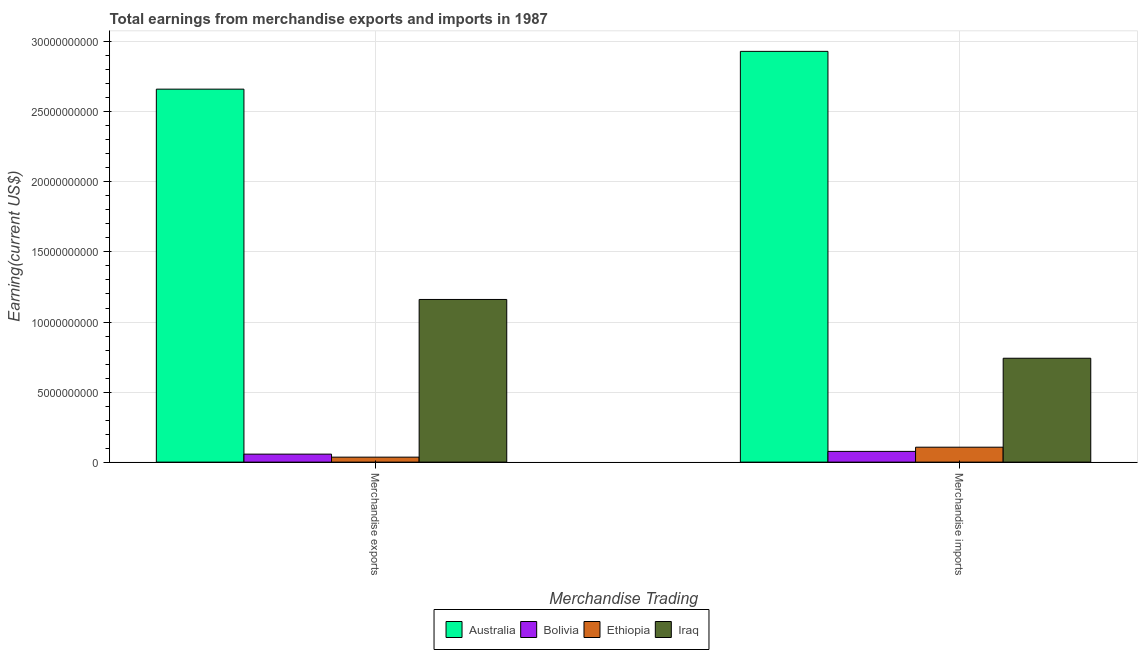Are the number of bars per tick equal to the number of legend labels?
Give a very brief answer. Yes. Are the number of bars on each tick of the X-axis equal?
Your answer should be compact. Yes. How many bars are there on the 2nd tick from the left?
Offer a very short reply. 4. How many bars are there on the 2nd tick from the right?
Offer a very short reply. 4. What is the label of the 1st group of bars from the left?
Your answer should be compact. Merchandise exports. What is the earnings from merchandise imports in Iraq?
Ensure brevity in your answer.  7.42e+09. Across all countries, what is the maximum earnings from merchandise imports?
Offer a very short reply. 2.93e+1. Across all countries, what is the minimum earnings from merchandise exports?
Offer a very short reply. 3.55e+08. In which country was the earnings from merchandise imports maximum?
Your answer should be compact. Australia. What is the total earnings from merchandise exports in the graph?
Provide a succinct answer. 3.92e+1. What is the difference between the earnings from merchandise imports in Bolivia and that in Iraq?
Make the answer very short. -6.65e+09. What is the difference between the earnings from merchandise exports in Bolivia and the earnings from merchandise imports in Australia?
Keep it short and to the point. -2.87e+1. What is the average earnings from merchandise imports per country?
Provide a succinct answer. 9.64e+09. What is the difference between the earnings from merchandise imports and earnings from merchandise exports in Australia?
Your answer should be very brief. 2.70e+09. In how many countries, is the earnings from merchandise exports greater than 5000000000 US$?
Provide a succinct answer. 2. What is the ratio of the earnings from merchandise imports in Australia to that in Bolivia?
Ensure brevity in your answer.  38.27. Is the earnings from merchandise imports in Iraq less than that in Bolivia?
Give a very brief answer. No. What does the 4th bar from the left in Merchandise imports represents?
Ensure brevity in your answer.  Iraq. What does the 1st bar from the right in Merchandise exports represents?
Your answer should be very brief. Iraq. How many bars are there?
Your answer should be compact. 8. Are the values on the major ticks of Y-axis written in scientific E-notation?
Provide a succinct answer. No. Where does the legend appear in the graph?
Your answer should be compact. Bottom center. How are the legend labels stacked?
Your answer should be very brief. Horizontal. What is the title of the graph?
Your answer should be compact. Total earnings from merchandise exports and imports in 1987. What is the label or title of the X-axis?
Give a very brief answer. Merchandise Trading. What is the label or title of the Y-axis?
Offer a terse response. Earning(current US$). What is the Earning(current US$) in Australia in Merchandise exports?
Ensure brevity in your answer.  2.66e+1. What is the Earning(current US$) in Bolivia in Merchandise exports?
Offer a terse response. 5.70e+08. What is the Earning(current US$) of Ethiopia in Merchandise exports?
Provide a succinct answer. 3.55e+08. What is the Earning(current US$) in Iraq in Merchandise exports?
Offer a terse response. 1.16e+1. What is the Earning(current US$) of Australia in Merchandise imports?
Offer a terse response. 2.93e+1. What is the Earning(current US$) in Bolivia in Merchandise imports?
Ensure brevity in your answer.  7.66e+08. What is the Earning(current US$) of Ethiopia in Merchandise imports?
Your answer should be compact. 1.07e+09. What is the Earning(current US$) in Iraq in Merchandise imports?
Give a very brief answer. 7.42e+09. Across all Merchandise Trading, what is the maximum Earning(current US$) of Australia?
Your answer should be very brief. 2.93e+1. Across all Merchandise Trading, what is the maximum Earning(current US$) in Bolivia?
Your response must be concise. 7.66e+08. Across all Merchandise Trading, what is the maximum Earning(current US$) in Ethiopia?
Your answer should be compact. 1.07e+09. Across all Merchandise Trading, what is the maximum Earning(current US$) of Iraq?
Your answer should be compact. 1.16e+1. Across all Merchandise Trading, what is the minimum Earning(current US$) in Australia?
Your answer should be compact. 2.66e+1. Across all Merchandise Trading, what is the minimum Earning(current US$) of Bolivia?
Keep it short and to the point. 5.70e+08. Across all Merchandise Trading, what is the minimum Earning(current US$) in Ethiopia?
Ensure brevity in your answer.  3.55e+08. Across all Merchandise Trading, what is the minimum Earning(current US$) of Iraq?
Make the answer very short. 7.42e+09. What is the total Earning(current US$) of Australia in the graph?
Keep it short and to the point. 5.59e+1. What is the total Earning(current US$) in Bolivia in the graph?
Offer a very short reply. 1.34e+09. What is the total Earning(current US$) of Ethiopia in the graph?
Ensure brevity in your answer.  1.42e+09. What is the total Earning(current US$) in Iraq in the graph?
Offer a very short reply. 1.90e+1. What is the difference between the Earning(current US$) of Australia in Merchandise exports and that in Merchandise imports?
Offer a terse response. -2.70e+09. What is the difference between the Earning(current US$) in Bolivia in Merchandise exports and that in Merchandise imports?
Keep it short and to the point. -1.96e+08. What is the difference between the Earning(current US$) of Ethiopia in Merchandise exports and that in Merchandise imports?
Make the answer very short. -7.11e+08. What is the difference between the Earning(current US$) of Iraq in Merchandise exports and that in Merchandise imports?
Ensure brevity in your answer.  4.20e+09. What is the difference between the Earning(current US$) of Australia in Merchandise exports and the Earning(current US$) of Bolivia in Merchandise imports?
Provide a short and direct response. 2.59e+1. What is the difference between the Earning(current US$) in Australia in Merchandise exports and the Earning(current US$) in Ethiopia in Merchandise imports?
Your response must be concise. 2.56e+1. What is the difference between the Earning(current US$) of Australia in Merchandise exports and the Earning(current US$) of Iraq in Merchandise imports?
Keep it short and to the point. 1.92e+1. What is the difference between the Earning(current US$) of Bolivia in Merchandise exports and the Earning(current US$) of Ethiopia in Merchandise imports?
Offer a very short reply. -4.96e+08. What is the difference between the Earning(current US$) in Bolivia in Merchandise exports and the Earning(current US$) in Iraq in Merchandise imports?
Offer a very short reply. -6.84e+09. What is the difference between the Earning(current US$) of Ethiopia in Merchandise exports and the Earning(current US$) of Iraq in Merchandise imports?
Your answer should be very brief. -7.06e+09. What is the average Earning(current US$) in Australia per Merchandise Trading?
Offer a terse response. 2.80e+1. What is the average Earning(current US$) in Bolivia per Merchandise Trading?
Your answer should be very brief. 6.68e+08. What is the average Earning(current US$) of Ethiopia per Merchandise Trading?
Offer a terse response. 7.10e+08. What is the average Earning(current US$) of Iraq per Merchandise Trading?
Keep it short and to the point. 9.51e+09. What is the difference between the Earning(current US$) in Australia and Earning(current US$) in Bolivia in Merchandise exports?
Ensure brevity in your answer.  2.61e+1. What is the difference between the Earning(current US$) in Australia and Earning(current US$) in Ethiopia in Merchandise exports?
Offer a very short reply. 2.63e+1. What is the difference between the Earning(current US$) in Australia and Earning(current US$) in Iraq in Merchandise exports?
Your answer should be very brief. 1.50e+1. What is the difference between the Earning(current US$) of Bolivia and Earning(current US$) of Ethiopia in Merchandise exports?
Offer a terse response. 2.15e+08. What is the difference between the Earning(current US$) of Bolivia and Earning(current US$) of Iraq in Merchandise exports?
Ensure brevity in your answer.  -1.10e+1. What is the difference between the Earning(current US$) in Ethiopia and Earning(current US$) in Iraq in Merchandise exports?
Offer a very short reply. -1.13e+1. What is the difference between the Earning(current US$) in Australia and Earning(current US$) in Bolivia in Merchandise imports?
Keep it short and to the point. 2.86e+1. What is the difference between the Earning(current US$) of Australia and Earning(current US$) of Ethiopia in Merchandise imports?
Provide a short and direct response. 2.83e+1. What is the difference between the Earning(current US$) of Australia and Earning(current US$) of Iraq in Merchandise imports?
Provide a succinct answer. 2.19e+1. What is the difference between the Earning(current US$) in Bolivia and Earning(current US$) in Ethiopia in Merchandise imports?
Give a very brief answer. -3.00e+08. What is the difference between the Earning(current US$) in Bolivia and Earning(current US$) in Iraq in Merchandise imports?
Offer a terse response. -6.65e+09. What is the difference between the Earning(current US$) in Ethiopia and Earning(current US$) in Iraq in Merchandise imports?
Ensure brevity in your answer.  -6.35e+09. What is the ratio of the Earning(current US$) of Australia in Merchandise exports to that in Merchandise imports?
Provide a short and direct response. 0.91. What is the ratio of the Earning(current US$) in Bolivia in Merchandise exports to that in Merchandise imports?
Your answer should be compact. 0.74. What is the ratio of the Earning(current US$) in Ethiopia in Merchandise exports to that in Merchandise imports?
Your answer should be compact. 0.33. What is the ratio of the Earning(current US$) of Iraq in Merchandise exports to that in Merchandise imports?
Make the answer very short. 1.57. What is the difference between the highest and the second highest Earning(current US$) of Australia?
Your answer should be compact. 2.70e+09. What is the difference between the highest and the second highest Earning(current US$) of Bolivia?
Give a very brief answer. 1.96e+08. What is the difference between the highest and the second highest Earning(current US$) of Ethiopia?
Provide a short and direct response. 7.11e+08. What is the difference between the highest and the second highest Earning(current US$) in Iraq?
Your answer should be very brief. 4.20e+09. What is the difference between the highest and the lowest Earning(current US$) in Australia?
Provide a short and direct response. 2.70e+09. What is the difference between the highest and the lowest Earning(current US$) of Bolivia?
Give a very brief answer. 1.96e+08. What is the difference between the highest and the lowest Earning(current US$) of Ethiopia?
Ensure brevity in your answer.  7.11e+08. What is the difference between the highest and the lowest Earning(current US$) in Iraq?
Provide a short and direct response. 4.20e+09. 